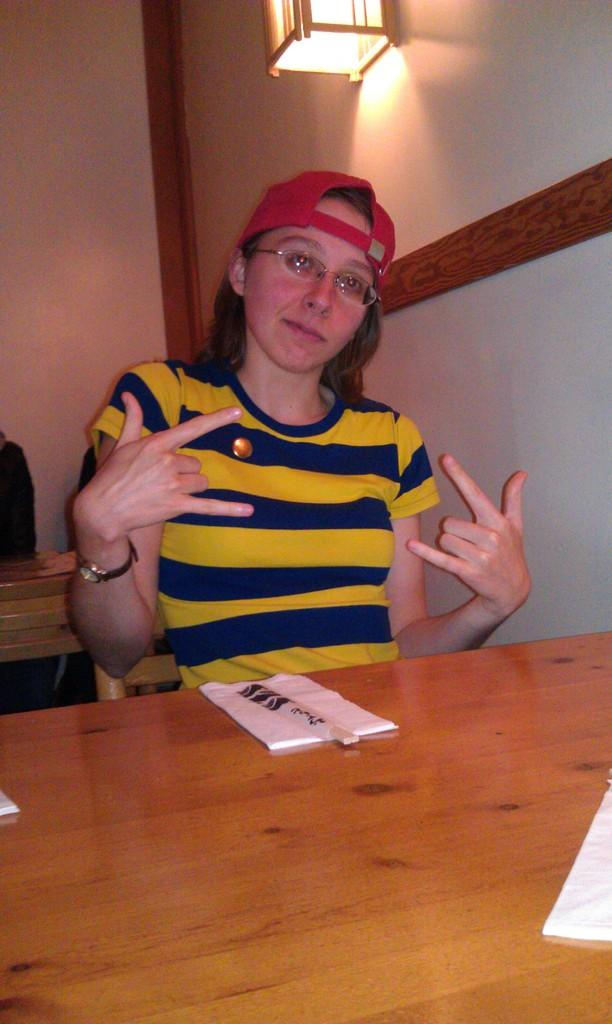What is the person in the image doing? There is a person sitting in the image. What can be seen on the wooden surface? There are objects on a wooden surface in the image. How many chairs are visible in the image? There are chairs in the image. What is on the wall in the image? There is a wall with objects in the image. What provides illumination in the image? There is a light in the image. Can you see a rat or a snake in the image? There is no rat or snake present in the image. What type of coast can be seen in the image? There is no coast visible in the image. 